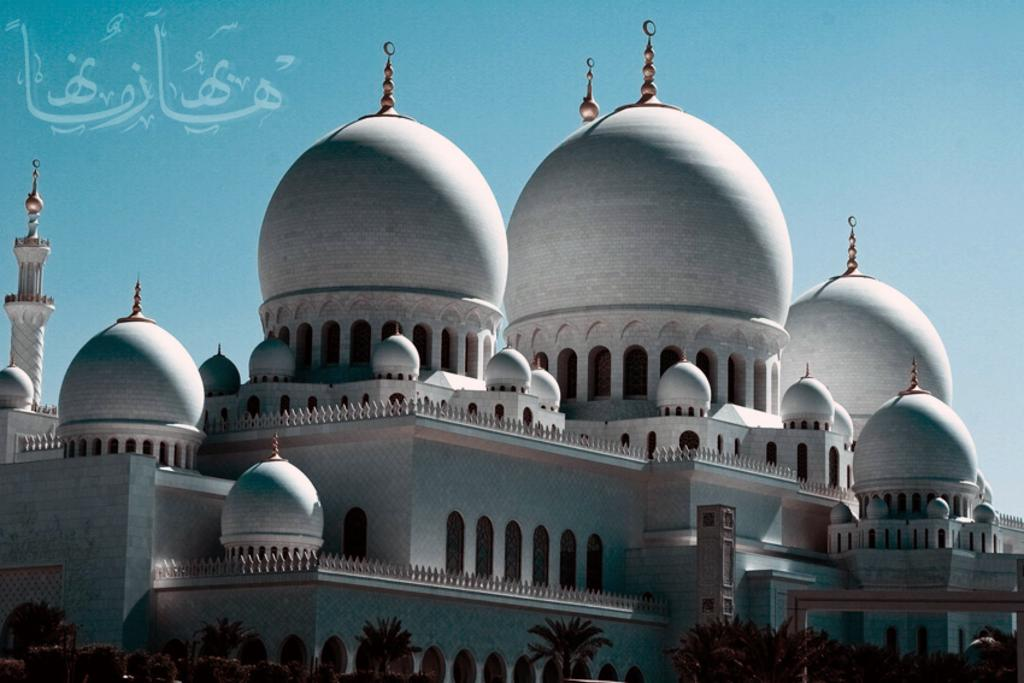What type of structure is present in the image? There is a building in the image. What can be seen at the bottom of the image? There are trees at the bottom of the image. What part of the natural environment is visible in the image? The sky is visible in the background of the image. What type of knowledge can be gained from the plantation in the image? There is no plantation present in the image, so no knowledge can be gained from it. 